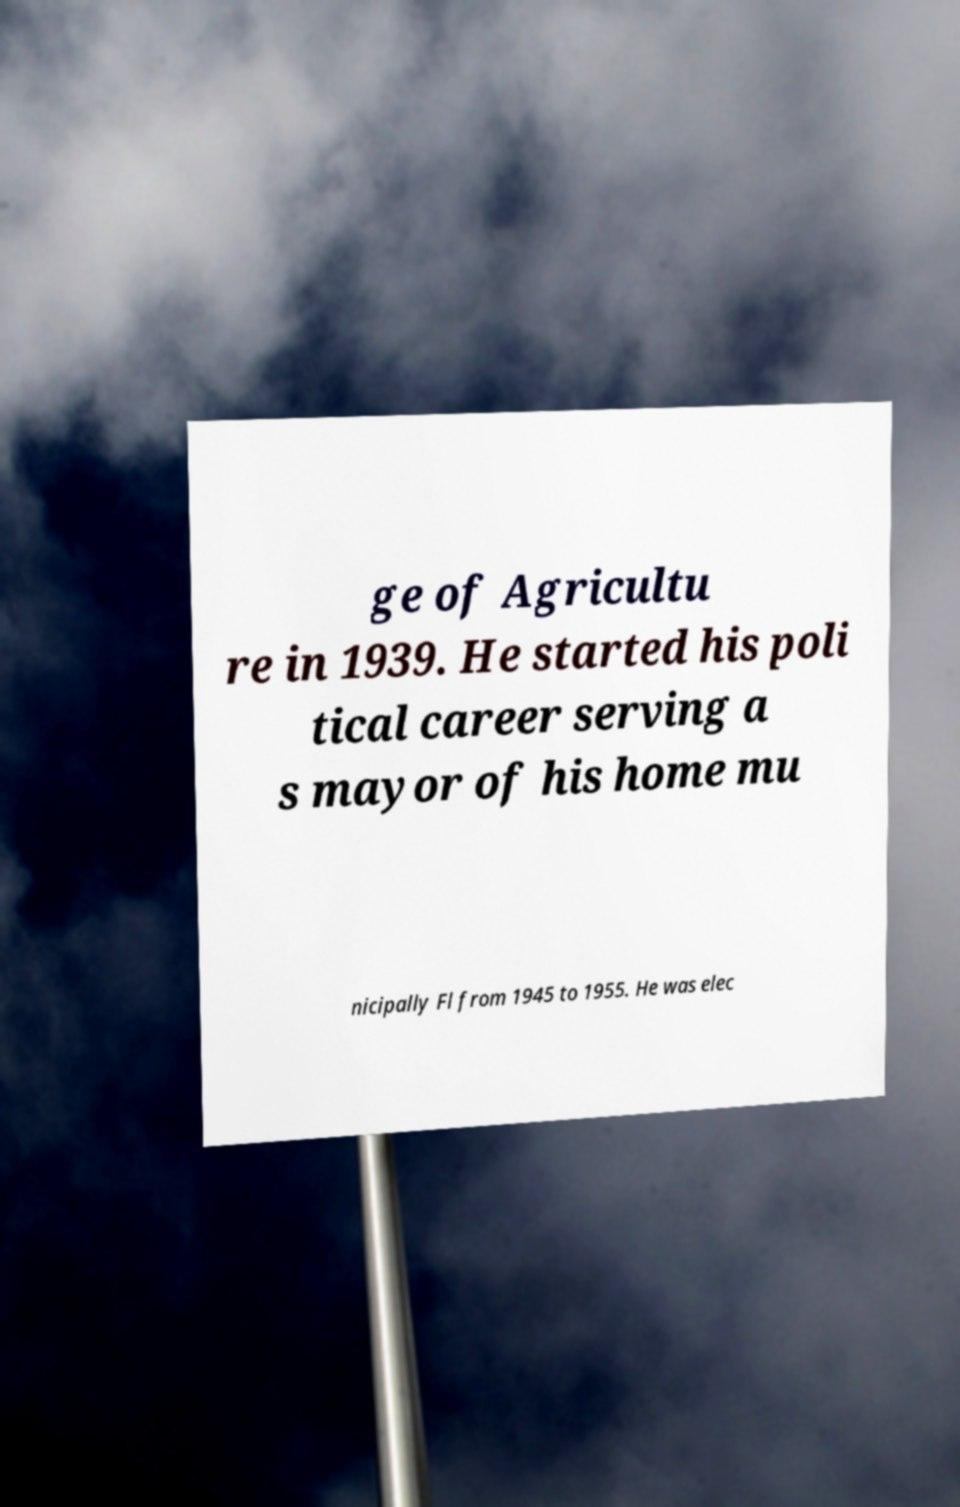Please identify and transcribe the text found in this image. ge of Agricultu re in 1939. He started his poli tical career serving a s mayor of his home mu nicipally Fl from 1945 to 1955. He was elec 